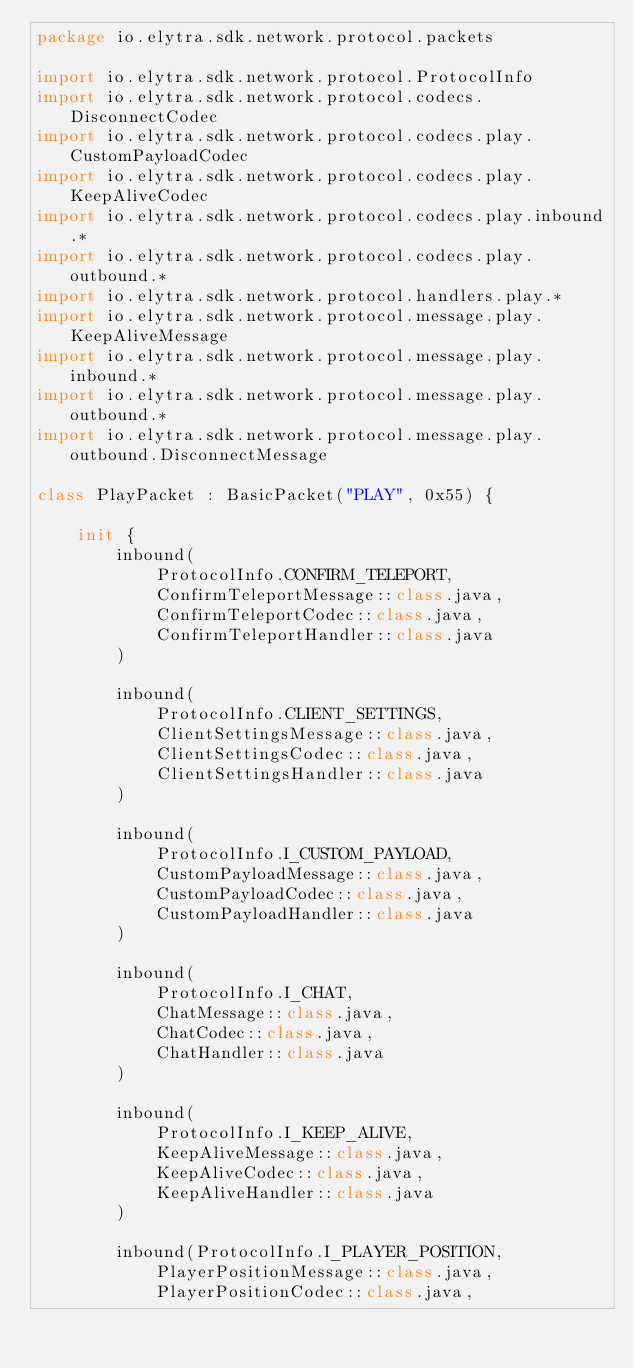<code> <loc_0><loc_0><loc_500><loc_500><_Kotlin_>package io.elytra.sdk.network.protocol.packets

import io.elytra.sdk.network.protocol.ProtocolInfo
import io.elytra.sdk.network.protocol.codecs.DisconnectCodec
import io.elytra.sdk.network.protocol.codecs.play.CustomPayloadCodec
import io.elytra.sdk.network.protocol.codecs.play.KeepAliveCodec
import io.elytra.sdk.network.protocol.codecs.play.inbound.*
import io.elytra.sdk.network.protocol.codecs.play.outbound.*
import io.elytra.sdk.network.protocol.handlers.play.*
import io.elytra.sdk.network.protocol.message.play.KeepAliveMessage
import io.elytra.sdk.network.protocol.message.play.inbound.*
import io.elytra.sdk.network.protocol.message.play.outbound.*
import io.elytra.sdk.network.protocol.message.play.outbound.DisconnectMessage

class PlayPacket : BasicPacket("PLAY", 0x55) {

    init {
        inbound(
            ProtocolInfo.CONFIRM_TELEPORT,
            ConfirmTeleportMessage::class.java,
            ConfirmTeleportCodec::class.java,
            ConfirmTeleportHandler::class.java
        )

        inbound(
            ProtocolInfo.CLIENT_SETTINGS,
            ClientSettingsMessage::class.java,
            ClientSettingsCodec::class.java,
            ClientSettingsHandler::class.java
        )

        inbound(
            ProtocolInfo.I_CUSTOM_PAYLOAD,
            CustomPayloadMessage::class.java,
            CustomPayloadCodec::class.java,
            CustomPayloadHandler::class.java
        )

        inbound(
            ProtocolInfo.I_CHAT,
            ChatMessage::class.java,
            ChatCodec::class.java,
            ChatHandler::class.java
        )

        inbound(
            ProtocolInfo.I_KEEP_ALIVE,
            KeepAliveMessage::class.java,
            KeepAliveCodec::class.java,
            KeepAliveHandler::class.java
        )

        inbound(ProtocolInfo.I_PLAYER_POSITION,
            PlayerPositionMessage::class.java,
            PlayerPositionCodec::class.java,</code> 